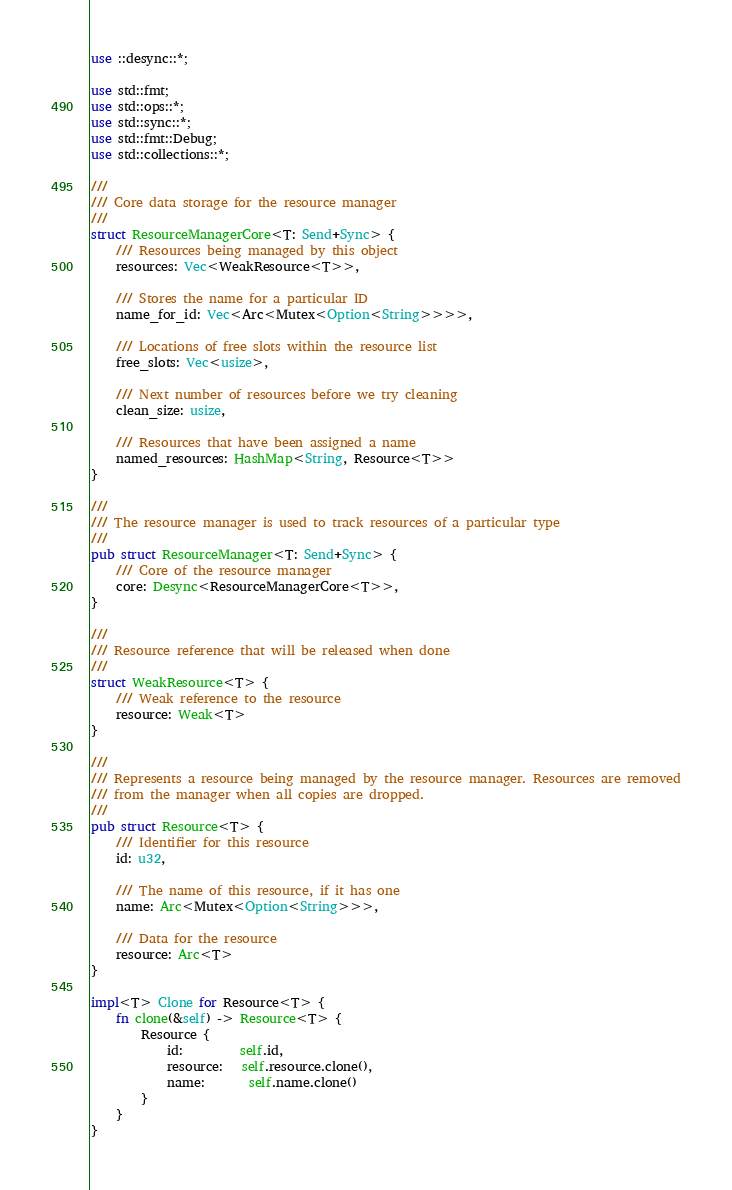Convert code to text. <code><loc_0><loc_0><loc_500><loc_500><_Rust_>use ::desync::*;

use std::fmt;
use std::ops::*;
use std::sync::*;
use std::fmt::Debug;
use std::collections::*;

///
/// Core data storage for the resource manager
///
struct ResourceManagerCore<T: Send+Sync> {
    /// Resources being managed by this object
    resources: Vec<WeakResource<T>>,

    /// Stores the name for a particular ID
    name_for_id: Vec<Arc<Mutex<Option<String>>>>,

    /// Locations of free slots within the resource list
    free_slots: Vec<usize>,

    /// Next number of resources before we try cleaning
    clean_size: usize,

    /// Resources that have been assigned a name
    named_resources: HashMap<String, Resource<T>>
}

///
/// The resource manager is used to track resources of a particular type
///
pub struct ResourceManager<T: Send+Sync> {
    /// Core of the resource manager
    core: Desync<ResourceManagerCore<T>>,
}

///
/// Resource reference that will be released when done
///
struct WeakResource<T> {
    /// Weak reference to the resource
    resource: Weak<T>
}

///
/// Represents a resource being managed by the resource manager. Resources are removed
/// from the manager when all copies are dropped.
///
pub struct Resource<T> {
    /// Identifier for this resource
    id: u32,

    /// The name of this resource, if it has one
    name: Arc<Mutex<Option<String>>>,

    /// Data for the resource
    resource: Arc<T>
}

impl<T> Clone for Resource<T> {
    fn clone(&self) -> Resource<T> {
        Resource {
            id:         self.id,
            resource:   self.resource.clone(),
            name:       self.name.clone()
        }
    }
}
</code> 